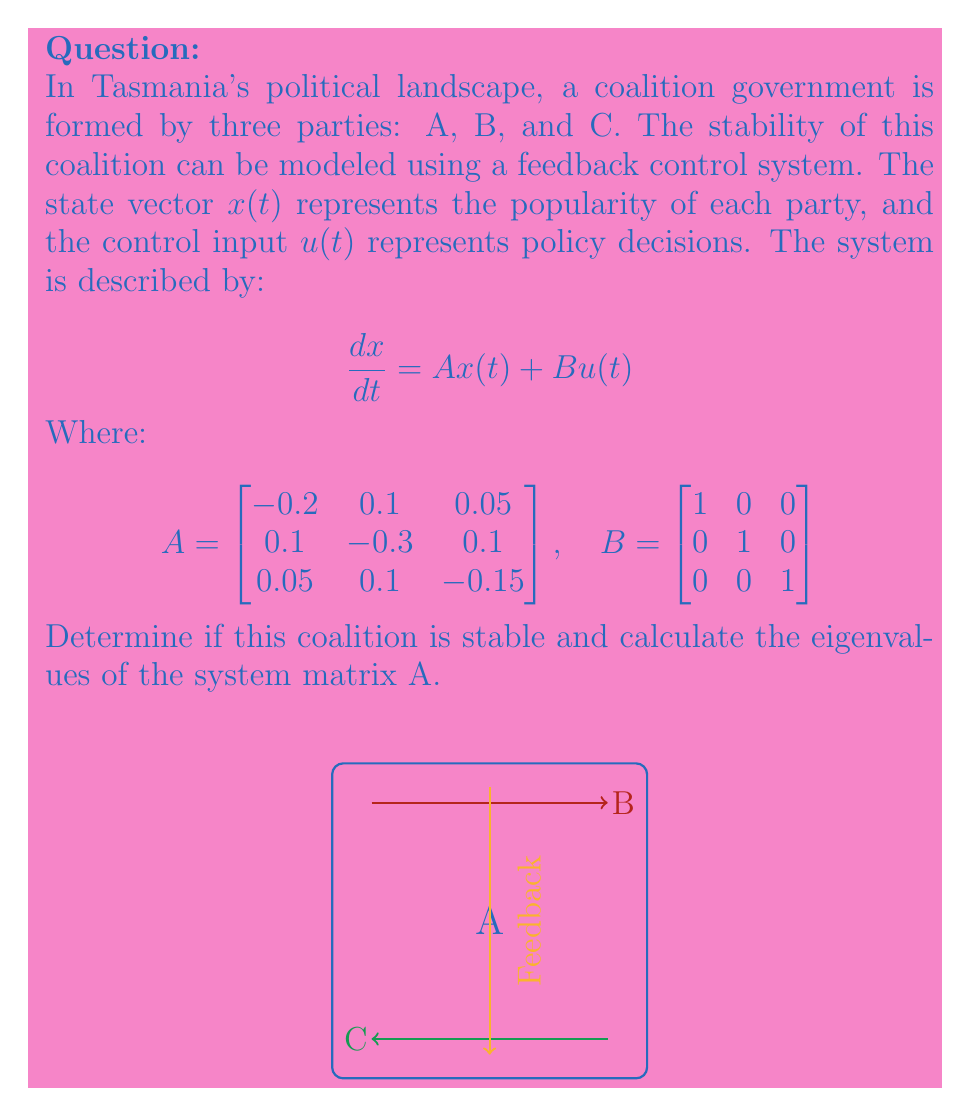Provide a solution to this math problem. To determine the stability of the coalition and calculate the eigenvalues of the system matrix A, we follow these steps:

1) A system is stable if all eigenvalues of the system matrix A have negative real parts.

2) To find the eigenvalues, we need to solve the characteristic equation:

   $$det(A - \lambda I) = 0$$

   Where $I$ is the 3x3 identity matrix and $\lambda$ represents the eigenvalues.

3) Expanding the determinant:

   $$\begin{vmatrix}
   -0.2-\lambda & 0.1 & 0.05 \\
   0.1 & -0.3-\lambda & 0.1 \\
   0.05 & 0.1 & -0.15-\lambda
   \end{vmatrix} = 0$$

4) This gives us the characteristic polynomial:

   $$-\lambda^3 - 0.65\lambda^2 - 0.1325\lambda - 0.0075 = 0$$

5) Solving this equation (using a numerical method or computer algebra system) gives us the eigenvalues:

   $$\lambda_1 \approx -0.5393$$
   $$\lambda_2 \approx -0.0804 + 0.1036i$$
   $$\lambda_3 \approx -0.0804 - 0.1036i$$

6) Since all eigenvalues have negative real parts, the system is stable.

Therefore, the coalition government modeled by this system is stable, as all parties' popularities will eventually converge to an equilibrium state after any perturbation.
Answer: Stable; Eigenvalues: $-0.5393, -0.0804 \pm 0.1036i$ 